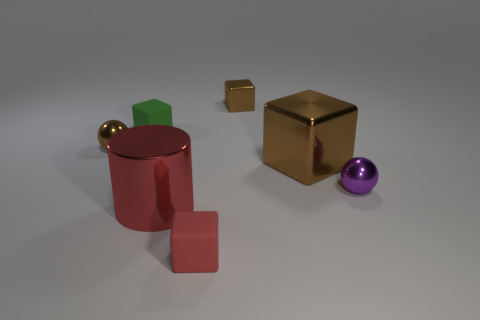There is a brown sphere that is the same size as the green rubber cube; what material is it?
Provide a succinct answer. Metal. What is the material of the other brown thing that is the same shape as the large brown thing?
Your answer should be compact. Metal. How many other objects are there of the same size as the red matte thing?
Provide a succinct answer. 4. What is the size of the rubber block that is the same color as the large cylinder?
Provide a succinct answer. Small. How many metallic objects have the same color as the metal cylinder?
Keep it short and to the point. 0. What is the shape of the large red object?
Ensure brevity in your answer.  Cylinder. What is the color of the small object that is in front of the green thing and on the left side of the big red metal cylinder?
Make the answer very short. Brown. What is the tiny green cube made of?
Your answer should be very brief. Rubber. What shape is the matte thing that is in front of the tiny green matte thing?
Make the answer very short. Cube. There is another ball that is the same size as the brown ball; what is its color?
Offer a terse response. Purple. 